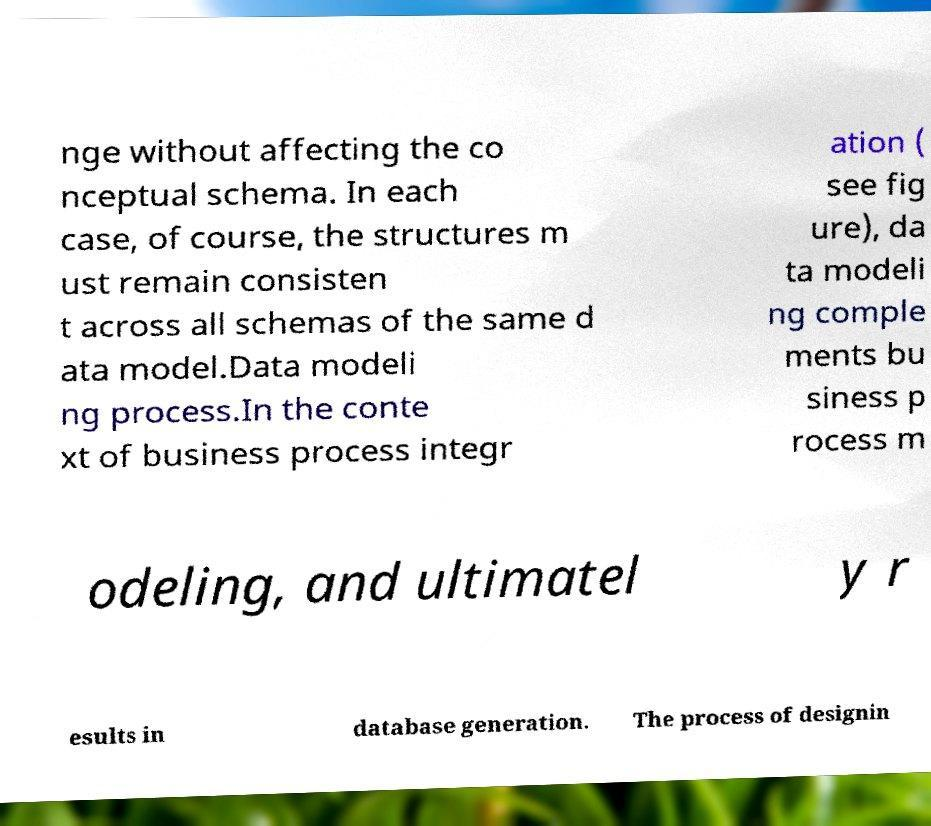What messages or text are displayed in this image? I need them in a readable, typed format. nge without affecting the co nceptual schema. In each case, of course, the structures m ust remain consisten t across all schemas of the same d ata model.Data modeli ng process.In the conte xt of business process integr ation ( see fig ure), da ta modeli ng comple ments bu siness p rocess m odeling, and ultimatel y r esults in database generation. The process of designin 